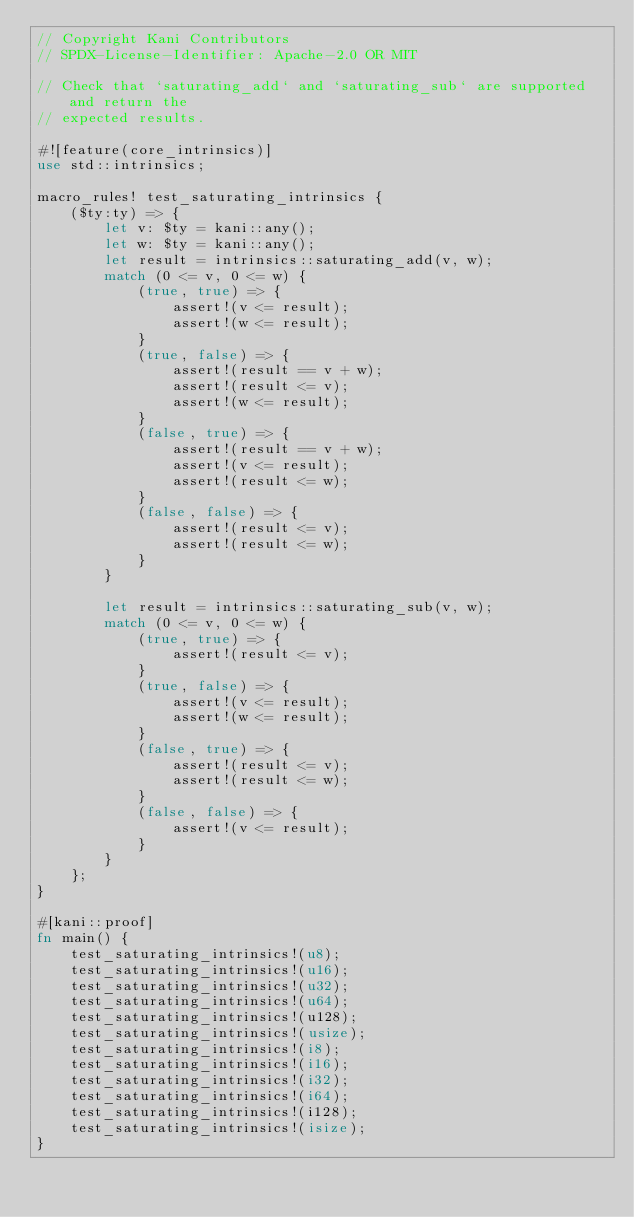<code> <loc_0><loc_0><loc_500><loc_500><_Rust_>// Copyright Kani Contributors
// SPDX-License-Identifier: Apache-2.0 OR MIT

// Check that `saturating_add` and `saturating_sub` are supported and return the
// expected results.

#![feature(core_intrinsics)]
use std::intrinsics;

macro_rules! test_saturating_intrinsics {
    ($ty:ty) => {
        let v: $ty = kani::any();
        let w: $ty = kani::any();
        let result = intrinsics::saturating_add(v, w);
        match (0 <= v, 0 <= w) {
            (true, true) => {
                assert!(v <= result);
                assert!(w <= result);
            }
            (true, false) => {
                assert!(result == v + w);
                assert!(result <= v);
                assert!(w <= result);
            }
            (false, true) => {
                assert!(result == v + w);
                assert!(v <= result);
                assert!(result <= w);
            }
            (false, false) => {
                assert!(result <= v);
                assert!(result <= w);
            }
        }

        let result = intrinsics::saturating_sub(v, w);
        match (0 <= v, 0 <= w) {
            (true, true) => {
                assert!(result <= v);
            }
            (true, false) => {
                assert!(v <= result);
                assert!(w <= result);
            }
            (false, true) => {
                assert!(result <= v);
                assert!(result <= w);
            }
            (false, false) => {
                assert!(v <= result);
            }
        }
    };
}

#[kani::proof]
fn main() {
    test_saturating_intrinsics!(u8);
    test_saturating_intrinsics!(u16);
    test_saturating_intrinsics!(u32);
    test_saturating_intrinsics!(u64);
    test_saturating_intrinsics!(u128);
    test_saturating_intrinsics!(usize);
    test_saturating_intrinsics!(i8);
    test_saturating_intrinsics!(i16);
    test_saturating_intrinsics!(i32);
    test_saturating_intrinsics!(i64);
    test_saturating_intrinsics!(i128);
    test_saturating_intrinsics!(isize);
}
</code> 